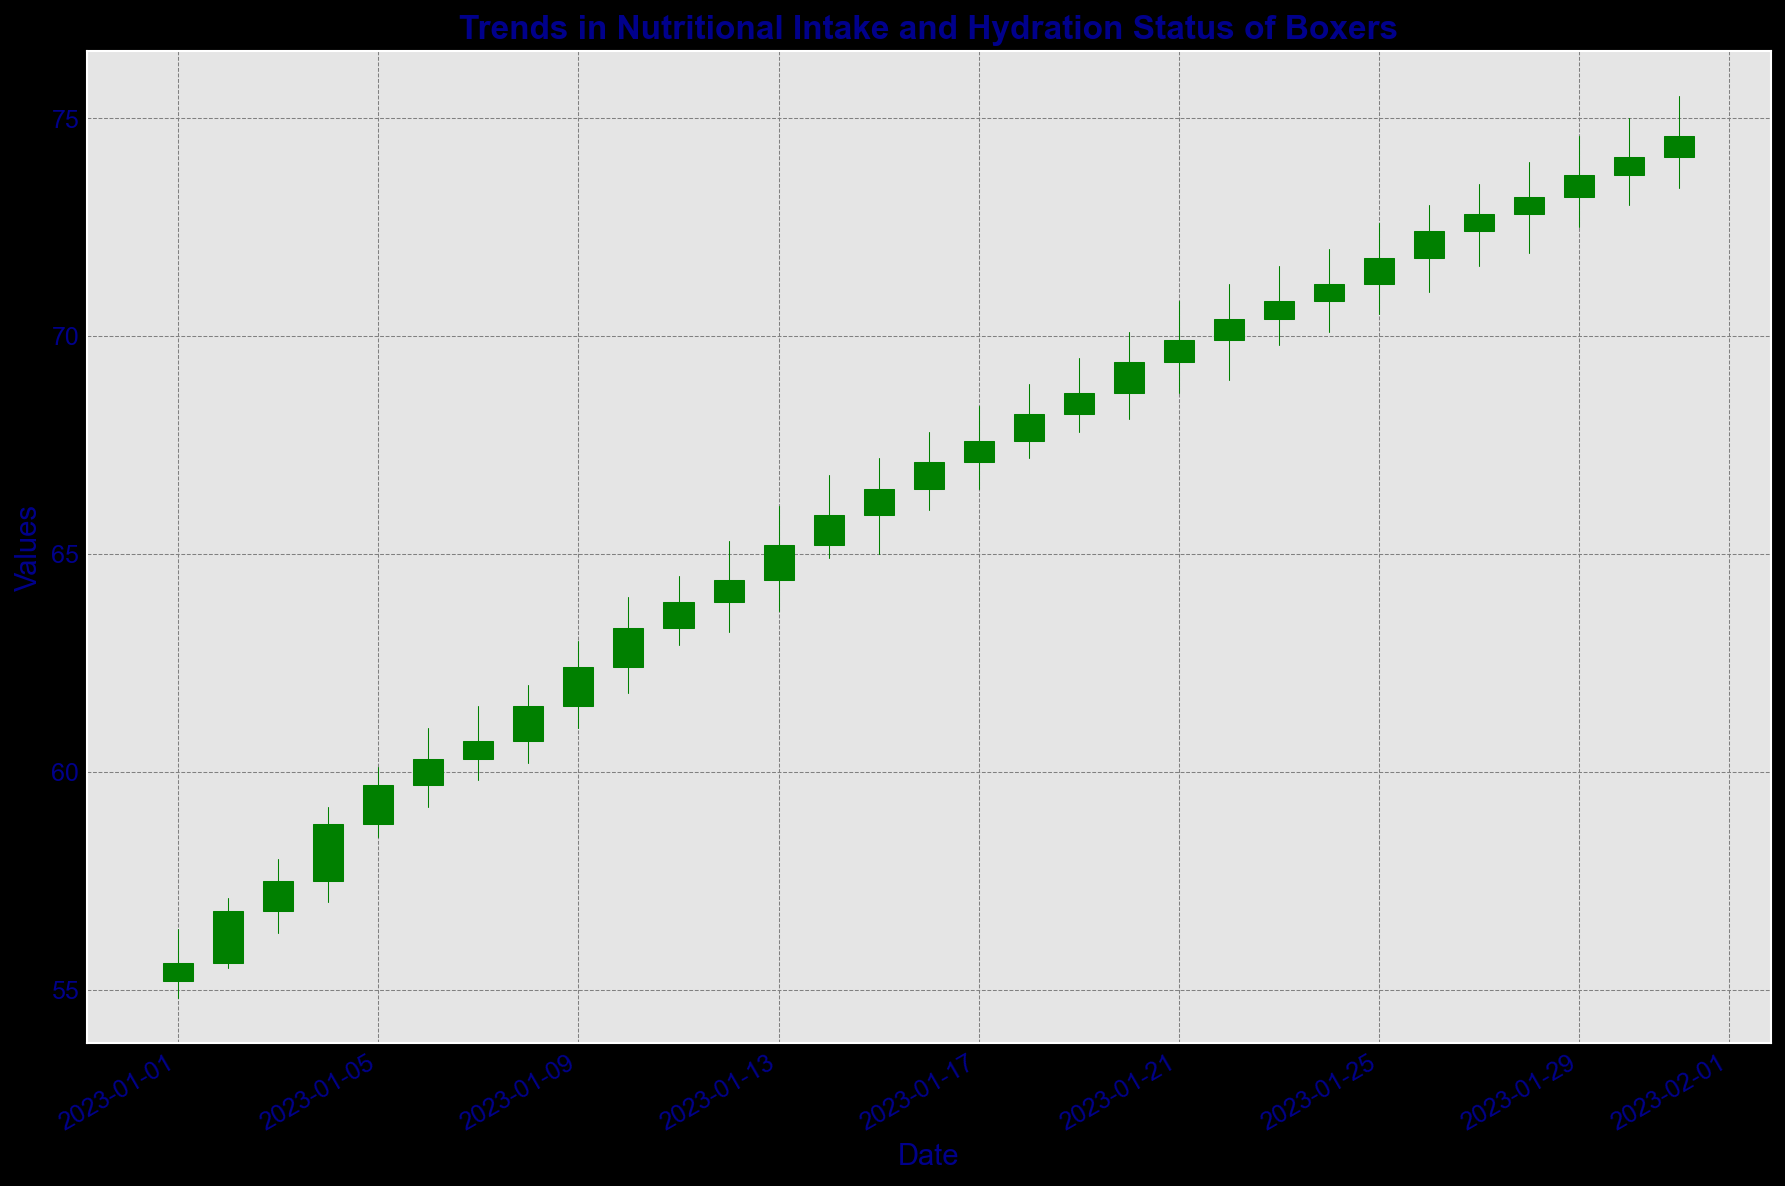What's the general trend in the values over the time period? The figure shows a candlestick chart with green and red bars depicting day-to-day value changes. Generally, there is an upward trend in the values, as evidenced by the candle positions and increasing high and low points from the beginning to the end of the period.
Answer: Upward trend Are there any periods where the values decreased consecutively for more than one day? Each red candlestick represents a day where the closing value is lower than the opening value. By observing the figure, there are no consecutive periods with red candlesticks that extend beyond one day.
Answer: No On which date was the highest value recorded, and what was it? The highest value on the candlestick chart corresponds to the top of the green bar (the high). By scanning the chart, January 31st shows the highest high value.
Answer: January 31st, 75.5 What's the difference between the highest and the lowest closing values in the period shown? The highest closing value is on January 31st (74.6) and the lowest closing value is on January 1st (55.6). The difference is 74.6 - 55.6.
Answer: 19 What was the average closing value in the first week? The first week consists of January 1st to January 7th. The closing values are 55.6, 56.8, 57.5, 58.8, 59.7, 60.3, and 60.7. Summing these values and dividing by 7 provides the average.
Answer: 58.2 Which day exhibited the largest single-day value increase, and what was the magnitude of the increase? The largest increase would be observed where the green candlestick is tallest from its bottom to top. By examining the figure, January 5th shows a significant jump. The difference is 59.7 - 58.8 = 0.9.
Answer: January 5th, 0.9 Were there any days with no change from the opening to closing value? A day with no change would have a horizontal line (no height) for its candlestick. By examining the figure, there are no candlesticks without height (indicating no change).
Answer: No What is the median closing value for the month of January? To find the median, list all closing values in ascending order. The middle value in the ordered set is the median. Given the total 31 days, the median value is the 16th value in the ordered list. By arranging and finding the median, it is close to the middle value.
Answer: Approximately 66.5 What can be said about the values from mid-January (15th) to the end of the month? The visual inspection of the figure shows that from January 15th to January 31st, the values continue their upward trend but with some fluctuations, there is consistent increment with green candles outnumbering the red ones.
Answer: Upward with fluctuations 